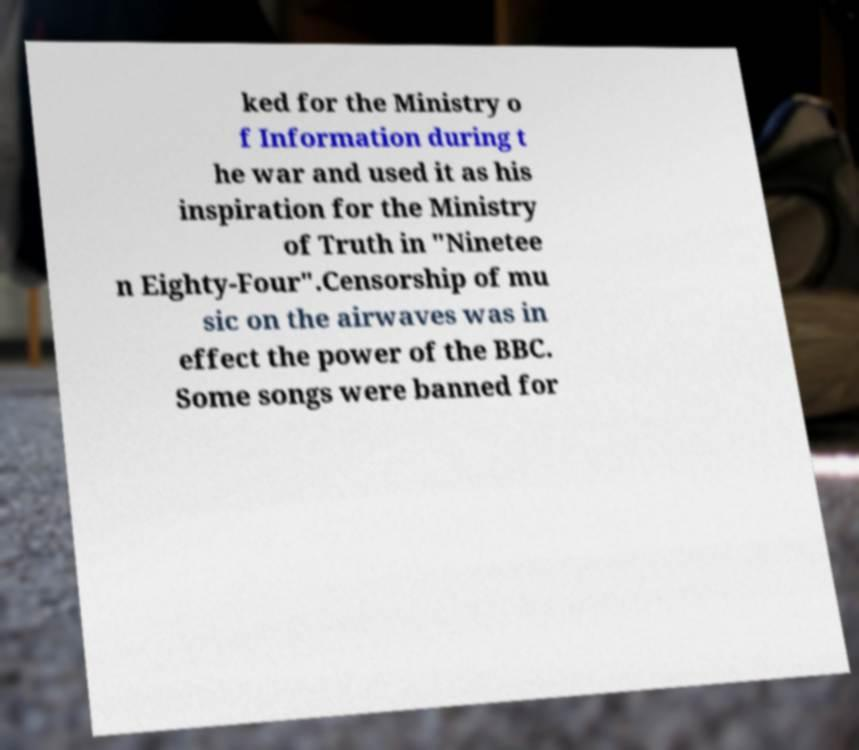Could you assist in decoding the text presented in this image and type it out clearly? ked for the Ministry o f Information during t he war and used it as his inspiration for the Ministry of Truth in "Ninetee n Eighty-Four".Censorship of mu sic on the airwaves was in effect the power of the BBC. Some songs were banned for 